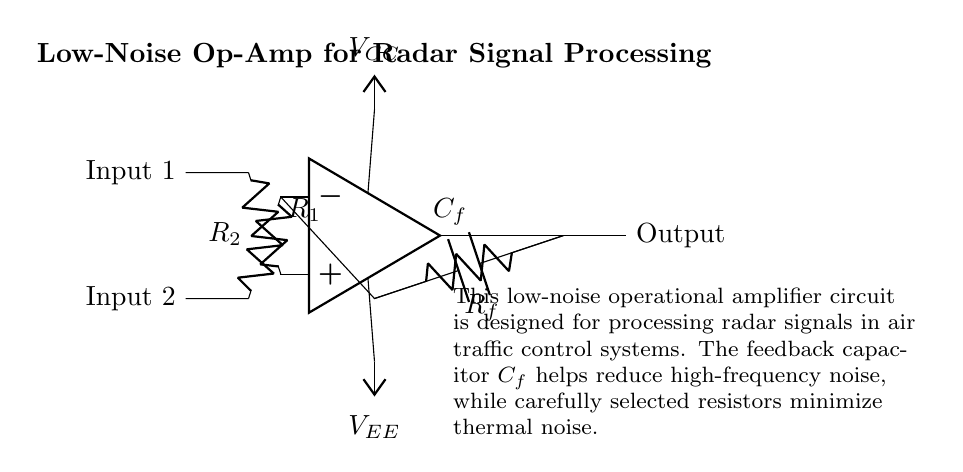What is the type of operational amplifier used in this circuit? The circuit diagram shows a generic operational amplifier symbol, indicating it is a low-noise operational amplifier designed for processing radar signals.
Answer: low-noise operational amplifier What does the feedback capacitor do in this circuit? The feedback capacitor is connected to reduce high-frequency noise that could affect the amplification of radar signals, providing better signal integrity.
Answer: reduce high-frequency noise What is the function of resistor R1? Resistor R1 is part of the inverting input of the operational amplifier, helping to set the gain of the amplifier along with R2 and Rf, contributing to the overall signal processing characteristics.
Answer: set the gain What are the supply voltages labeled in the circuit? The circuit contains two supply voltages: VCC at the top to provide positive power and VEE at the bottom for negative power, essential for op-amp operation.
Answer: VCC and VEE How does Rf impact the circuit? Resistor Rf provides feedback from the output to the inverting input, influencing the overall gain and stability of the circuit while reducing the noise in the amplified output signal.
Answer: influences gain and stability What is connected to the non-inverting input of the op-amp? The non-inverting input of the op-amp is connected to the first input signal through the resistor R1, allowing the operational amplifier to process this input for amplification.
Answer: first input signal What role does resistor R2 play? Resistor R2 is connected to the inverting input of the operational amplifier, working with R1 to set the desired gain of the circuit and stabilize the amplification process.
Answer: set the desired gain 